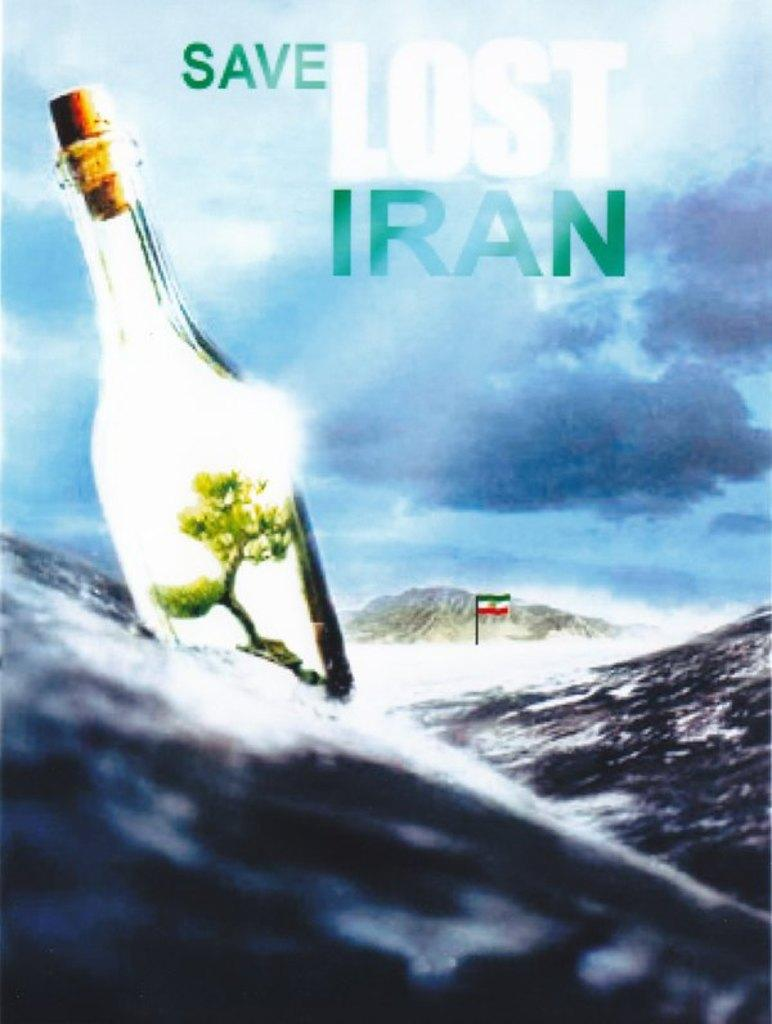<image>
Render a clear and concise summary of the photo. Save Lost Iran is on a poster of a bottle floating in the water with a tree inside of it. 